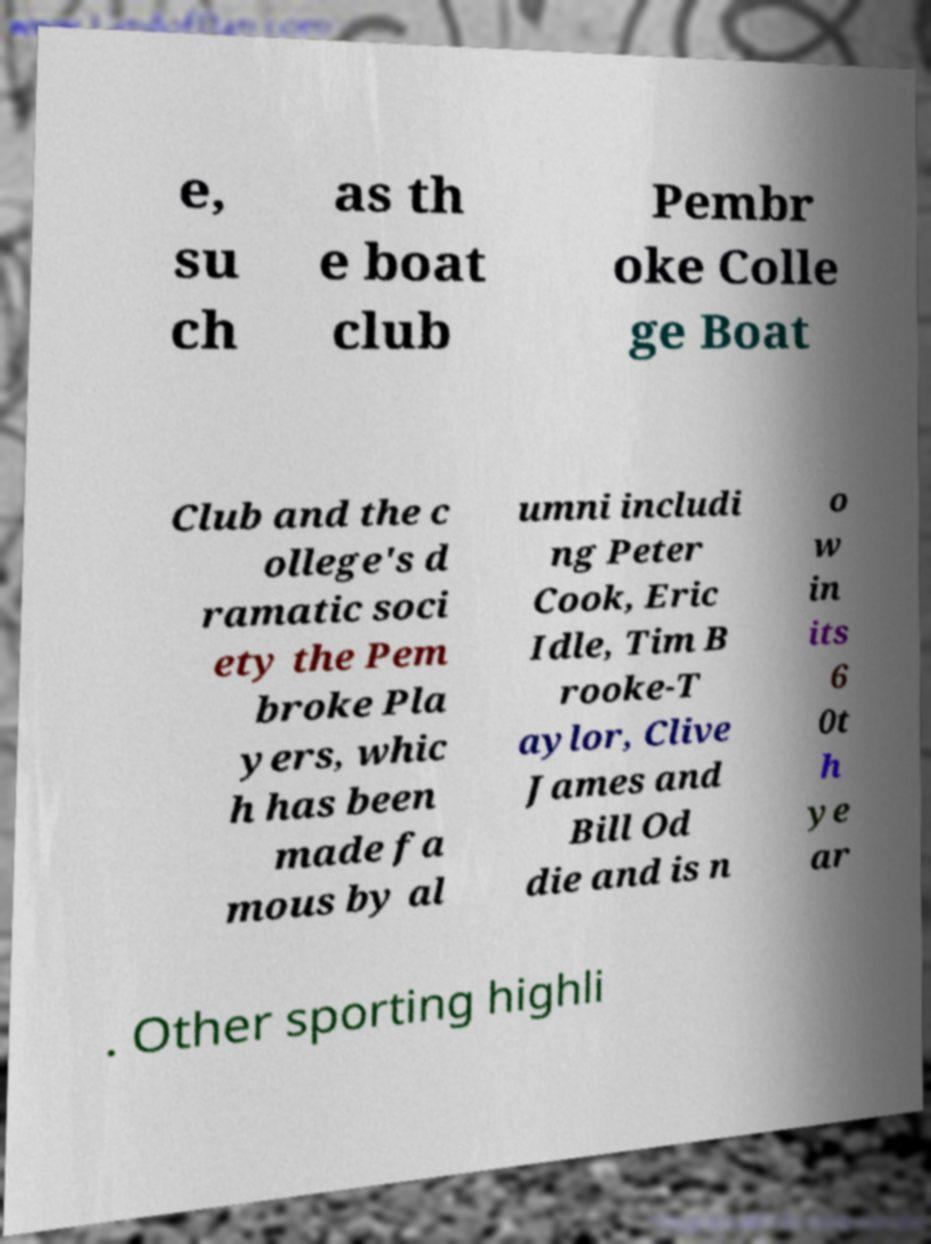For documentation purposes, I need the text within this image transcribed. Could you provide that? e, su ch as th e boat club Pembr oke Colle ge Boat Club and the c ollege's d ramatic soci ety the Pem broke Pla yers, whic h has been made fa mous by al umni includi ng Peter Cook, Eric Idle, Tim B rooke-T aylor, Clive James and Bill Od die and is n o w in its 6 0t h ye ar . Other sporting highli 